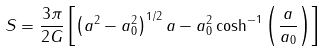<formula> <loc_0><loc_0><loc_500><loc_500>S = \frac { 3 \pi } { 2 G } \left [ \left ( a ^ { 2 } - a _ { 0 } ^ { 2 } \right ) ^ { 1 / 2 } a - a _ { 0 } ^ { 2 } \cosh ^ { - 1 } \left ( \frac { a } { a _ { 0 } } \right ) \right ]</formula> 